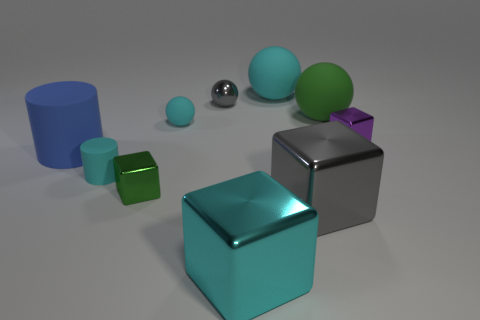Is the number of spheres greater than the number of large gray cubes?
Offer a very short reply. Yes. The small metal thing in front of the tiny cyan rubber cylinder has what shape?
Provide a succinct answer. Cube. What number of large green matte objects have the same shape as the small purple object?
Ensure brevity in your answer.  0. What is the size of the green object in front of the big sphere that is right of the large gray object?
Provide a succinct answer. Small. What number of red things are either big cubes or tiny metal objects?
Provide a short and direct response. 0. Are there fewer gray objects that are in front of the cyan shiny cube than large blue cylinders that are right of the large gray metallic thing?
Your answer should be very brief. No. There is a gray sphere; is its size the same as the ball on the right side of the large gray metal object?
Your answer should be very brief. No. How many blue matte cylinders are the same size as the green rubber thing?
Make the answer very short. 1. What number of tiny things are either cubes or brown rubber things?
Make the answer very short. 2. Are any tiny red matte things visible?
Keep it short and to the point. No. 